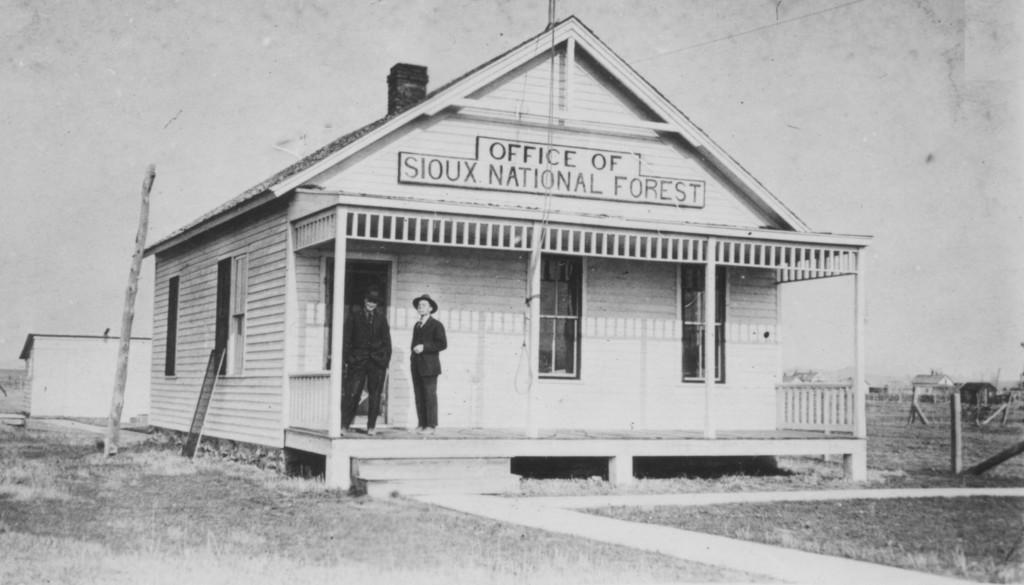How would you summarize this image in a sentence or two? In this picture I can see there is a building and there are two persons standing here and they are wearing black blazers and black caps and the building has windows and there is a name board at the top of the building and there is some grass on the floor and this is a black and white picture. 